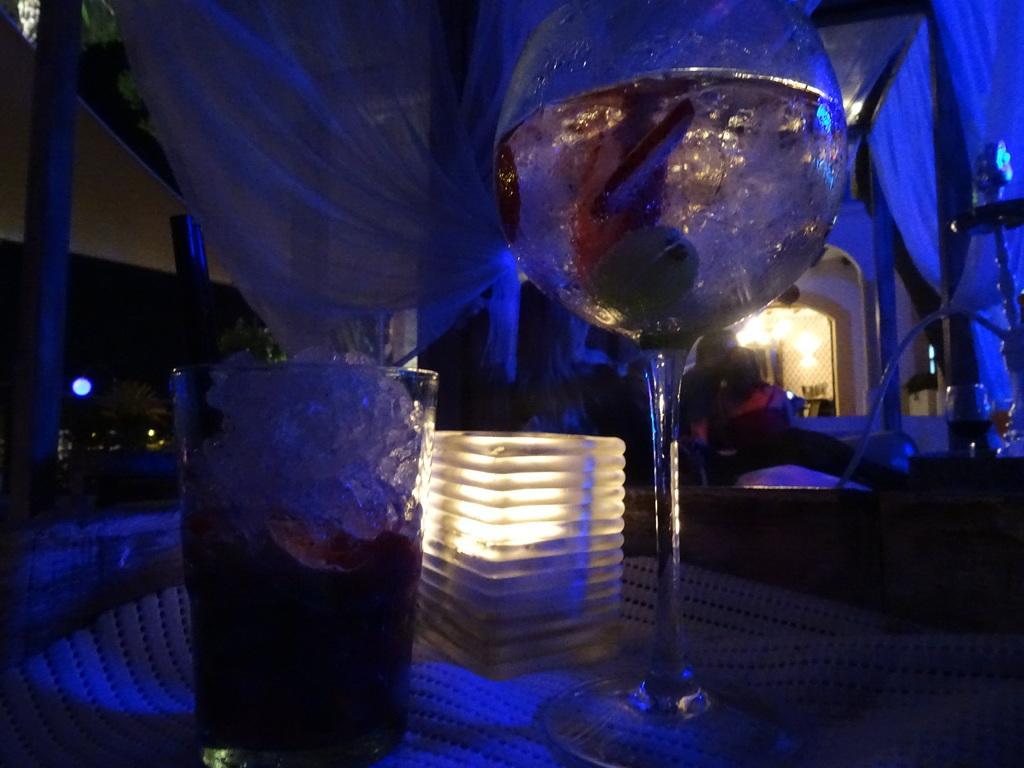Describe this image in one or two sentences. In this picture I can see couple of glasses and a light on the table and I can see few lights and a cloth on the back. 